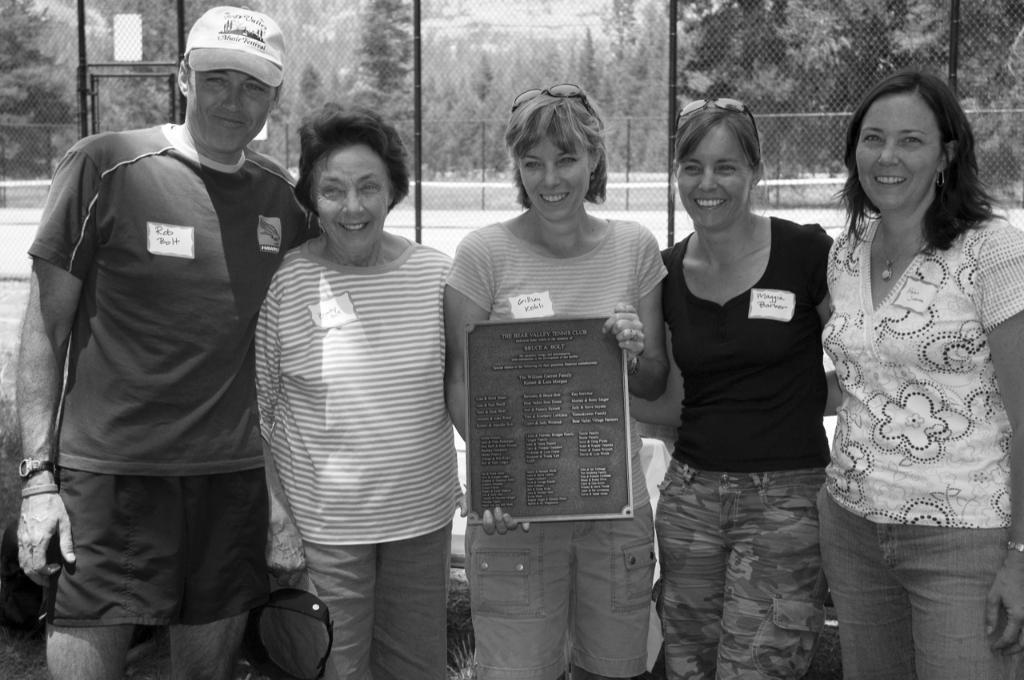Could you give a brief overview of what you see in this image? In this image I can see four women and a man is standing and smiling among them this woman is holding some object. In the background I can see fence and trees. This picture is black and white in color. 